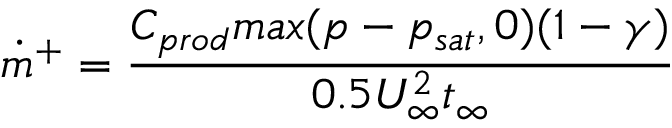<formula> <loc_0><loc_0><loc_500><loc_500>\dot { m } ^ { + } = \frac { C _ { p r o d } \max ( p - p _ { s a t } , 0 ) ( 1 - \gamma ) } { 0 . 5 U _ { \infty } ^ { 2 } t _ { \infty } }</formula> 